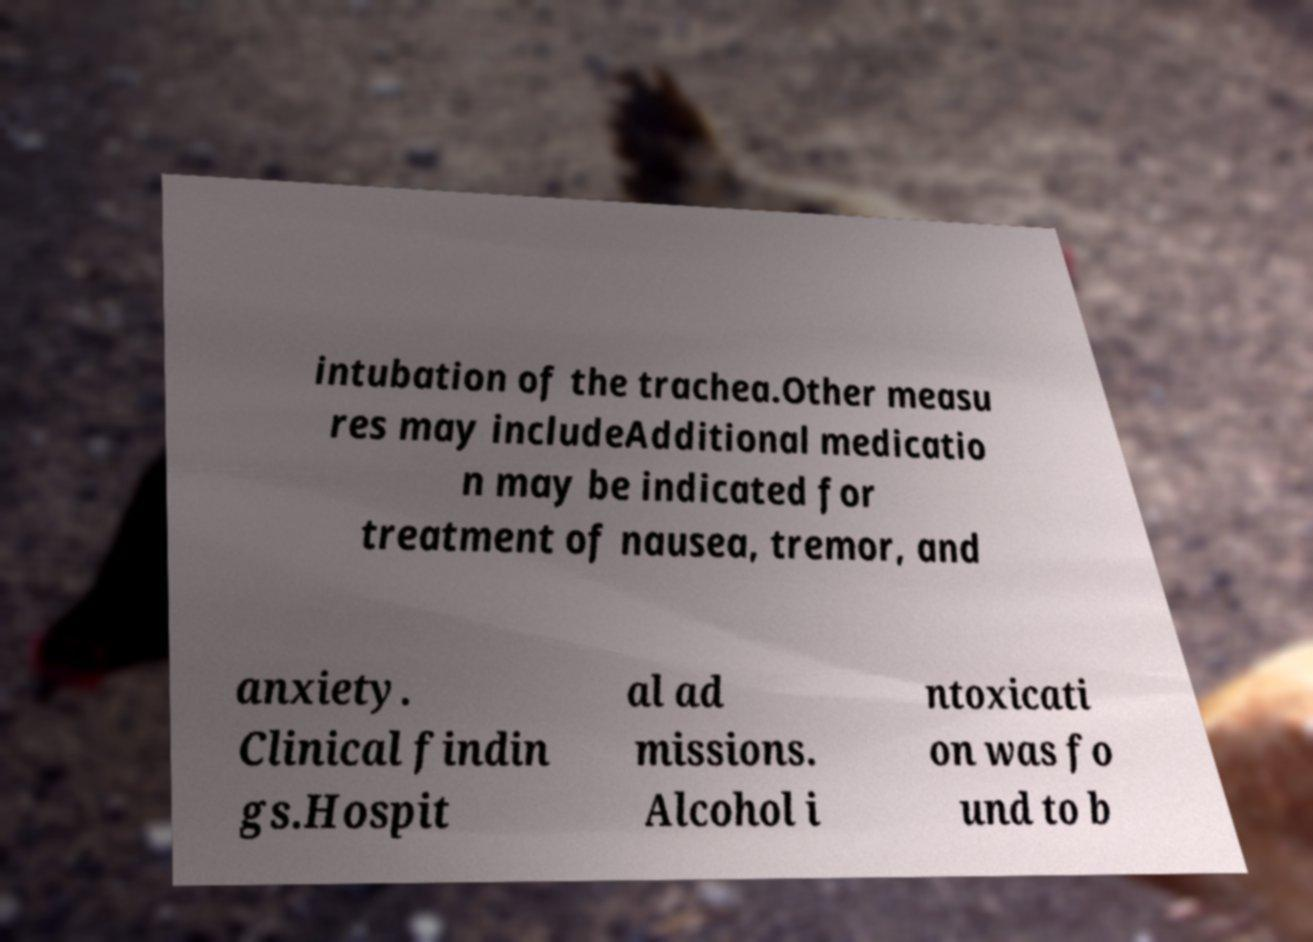There's text embedded in this image that I need extracted. Can you transcribe it verbatim? intubation of the trachea.Other measu res may includeAdditional medicatio n may be indicated for treatment of nausea, tremor, and anxiety. Clinical findin gs.Hospit al ad missions. Alcohol i ntoxicati on was fo und to b 